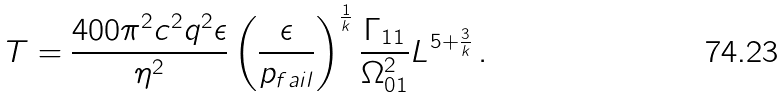<formula> <loc_0><loc_0><loc_500><loc_500>T = \frac { 4 0 0 \pi ^ { 2 } c ^ { 2 } q ^ { 2 } \epsilon } { \eta ^ { 2 } } \left ( \frac { \epsilon } { p _ { f a i l } } \right ) ^ { \frac { 1 } { k } } \frac { \Gamma _ { 1 1 } } { \Omega _ { 0 1 } ^ { 2 } } L ^ { 5 + \frac { 3 } { k } } \, .</formula> 